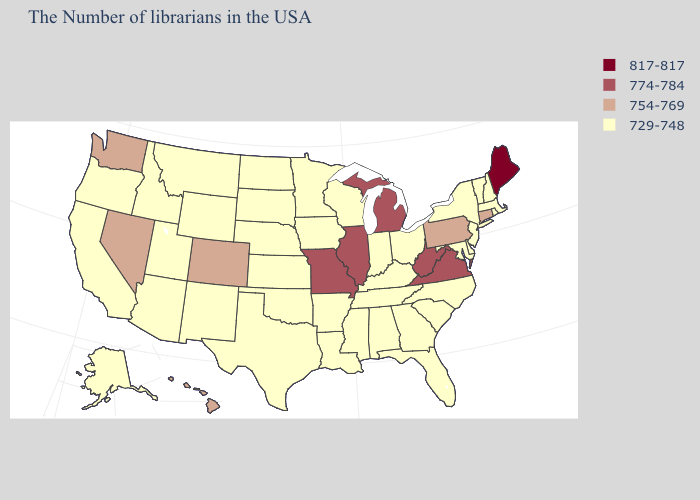Among the states that border Idaho , which have the highest value?
Concise answer only. Nevada, Washington. Does the first symbol in the legend represent the smallest category?
Short answer required. No. Name the states that have a value in the range 729-748?
Be succinct. Massachusetts, Rhode Island, New Hampshire, Vermont, New York, New Jersey, Delaware, Maryland, North Carolina, South Carolina, Ohio, Florida, Georgia, Kentucky, Indiana, Alabama, Tennessee, Wisconsin, Mississippi, Louisiana, Arkansas, Minnesota, Iowa, Kansas, Nebraska, Oklahoma, Texas, South Dakota, North Dakota, Wyoming, New Mexico, Utah, Montana, Arizona, Idaho, California, Oregon, Alaska. Which states have the highest value in the USA?
Answer briefly. Maine. What is the highest value in the USA?
Write a very short answer. 817-817. What is the highest value in the USA?
Quick response, please. 817-817. Name the states that have a value in the range 754-769?
Keep it brief. Connecticut, Pennsylvania, Colorado, Nevada, Washington, Hawaii. Which states have the highest value in the USA?
Write a very short answer. Maine. What is the value of Utah?
Concise answer only. 729-748. What is the value of Arizona?
Answer briefly. 729-748. Name the states that have a value in the range 817-817?
Keep it brief. Maine. Among the states that border North Carolina , does Virginia have the lowest value?
Concise answer only. No. What is the lowest value in states that border Tennessee?
Concise answer only. 729-748. Which states hav the highest value in the Northeast?
Quick response, please. Maine. Does Nevada have a lower value than Virginia?
Be succinct. Yes. 